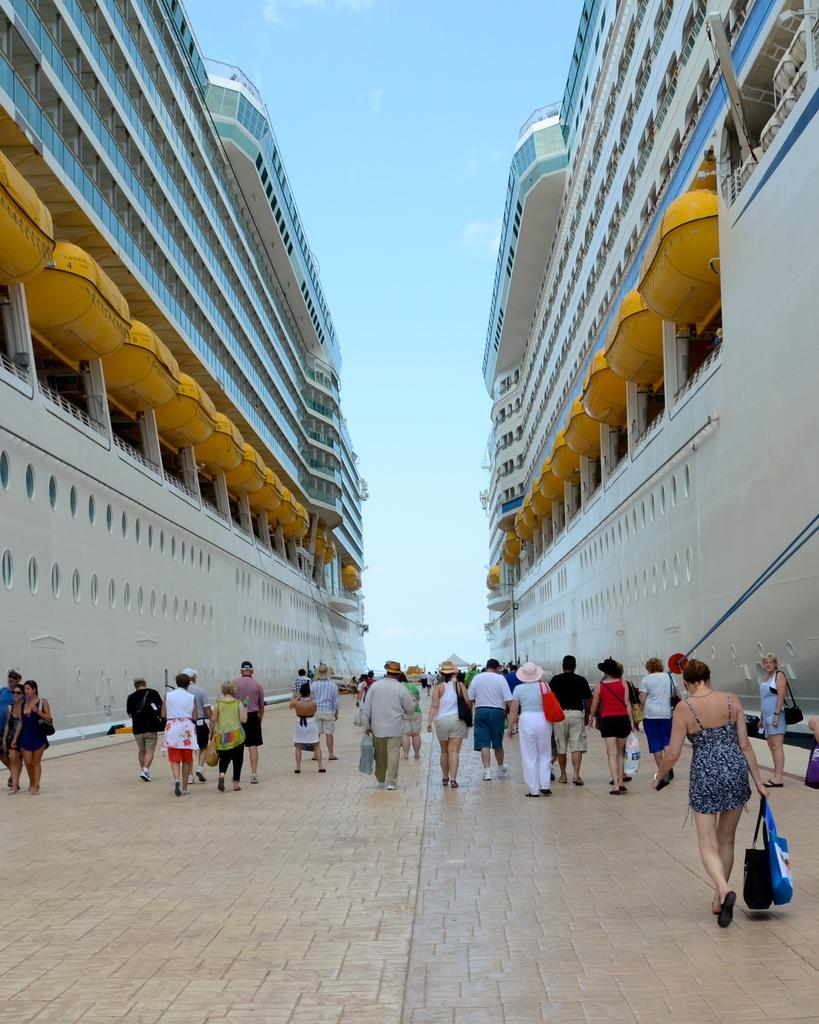What type of structures can be seen in the image? There are buildings in the image. What else is present in the image besides the buildings? There is a group of people in the image. What can be seen in the sky in the image? The sky is visible in the image. Can you describe the woman on the right side of the image? The woman is wearing a black color dress and is walking on the right side of the image. What is the woman holding in the image? The woman is holding a bag. Can you tell me how many apples are in the woman's bag in the image? There is no information about apples or the contents of the woman's bag in the image. What type of powder can be seen falling from the sky in the image? There is no powder falling from the sky in the image; only the buildings, group of people, sky, and woman are present. 